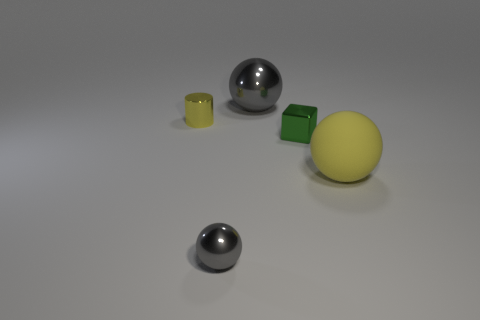Are there any small green metallic blocks in front of the large yellow matte ball?
Provide a short and direct response. No. Does the metal block have the same size as the gray thing behind the large yellow matte thing?
Provide a short and direct response. No. What is the color of the ball that is on the left side of the gray shiny ball that is behind the tiny yellow cylinder?
Your answer should be very brief. Gray. Is the size of the yellow rubber ball the same as the green shiny thing?
Your answer should be compact. No. The tiny metallic object that is both behind the yellow matte sphere and right of the tiny shiny cylinder is what color?
Offer a very short reply. Green. The rubber ball has what size?
Provide a short and direct response. Large. Does the thing that is behind the tiny yellow metal cylinder have the same color as the tiny metallic cylinder?
Give a very brief answer. No. Are there more large metallic balls that are left of the yellow metal thing than large yellow objects that are behind the large gray ball?
Your answer should be compact. No. Is the number of big red spheres greater than the number of big balls?
Your answer should be compact. No. There is a sphere that is in front of the small yellow metal cylinder and left of the large matte object; how big is it?
Ensure brevity in your answer.  Small. 